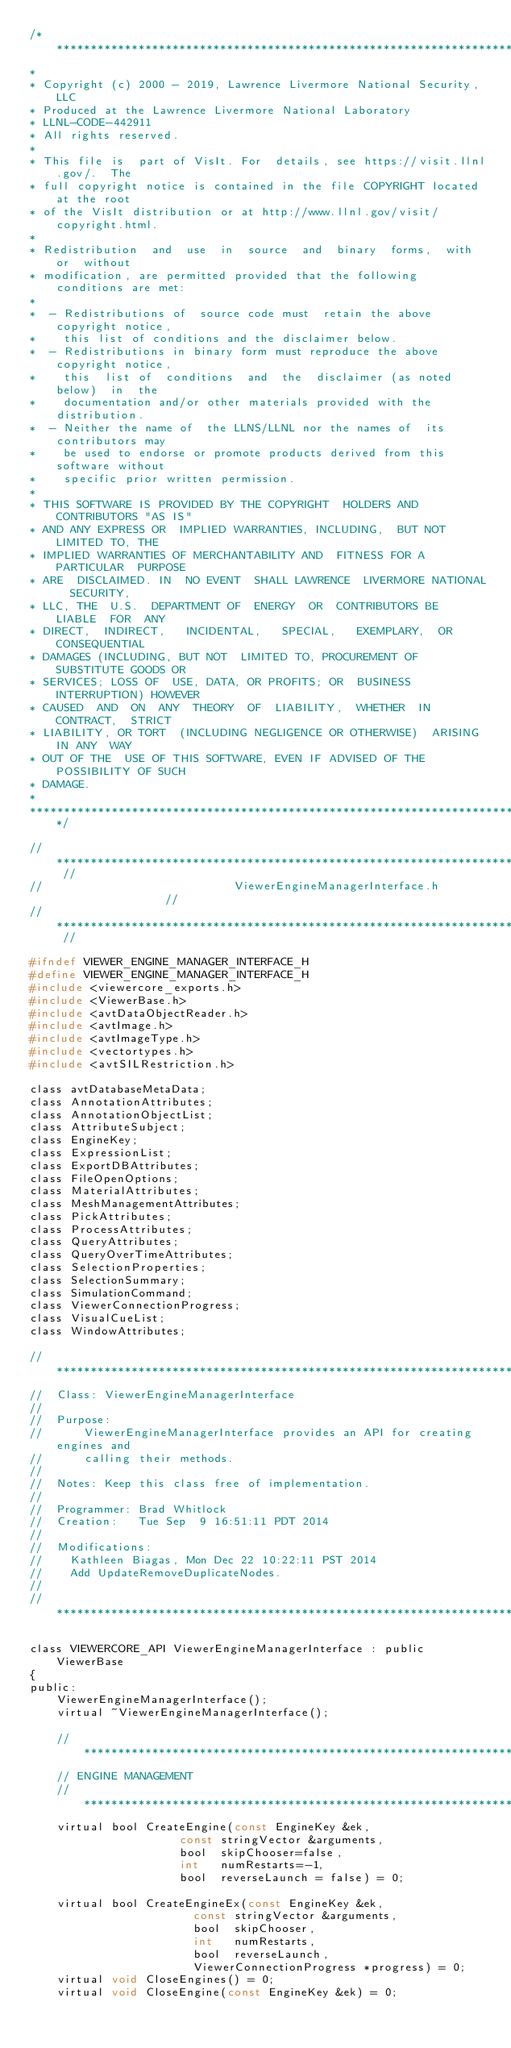Convert code to text. <code><loc_0><loc_0><loc_500><loc_500><_C_>/*****************************************************************************
*
* Copyright (c) 2000 - 2019, Lawrence Livermore National Security, LLC
* Produced at the Lawrence Livermore National Laboratory
* LLNL-CODE-442911
* All rights reserved.
*
* This file is  part of VisIt. For  details, see https://visit.llnl.gov/.  The
* full copyright notice is contained in the file COPYRIGHT located at the root
* of the VisIt distribution or at http://www.llnl.gov/visit/copyright.html.
*
* Redistribution  and  use  in  source  and  binary  forms,  with  or  without
* modification, are permitted provided that the following conditions are met:
*
*  - Redistributions of  source code must  retain the above  copyright notice,
*    this list of conditions and the disclaimer below.
*  - Redistributions in binary form must reproduce the above copyright notice,
*    this  list of  conditions  and  the  disclaimer (as noted below)  in  the
*    documentation and/or other materials provided with the distribution.
*  - Neither the name of  the LLNS/LLNL nor the names of  its contributors may
*    be used to endorse or promote products derived from this software without
*    specific prior written permission.
*
* THIS SOFTWARE IS PROVIDED BY THE COPYRIGHT  HOLDERS AND CONTRIBUTORS "AS IS"
* AND ANY EXPRESS OR  IMPLIED WARRANTIES, INCLUDING,  BUT NOT  LIMITED TO, THE
* IMPLIED WARRANTIES OF MERCHANTABILITY AND  FITNESS FOR A PARTICULAR  PURPOSE
* ARE  DISCLAIMED. IN  NO EVENT  SHALL LAWRENCE  LIVERMORE NATIONAL  SECURITY,
* LLC, THE  U.S.  DEPARTMENT OF  ENERGY  OR  CONTRIBUTORS BE  LIABLE  FOR  ANY
* DIRECT,  INDIRECT,   INCIDENTAL,   SPECIAL,   EXEMPLARY,  OR   CONSEQUENTIAL
* DAMAGES (INCLUDING, BUT NOT  LIMITED TO, PROCUREMENT OF  SUBSTITUTE GOODS OR
* SERVICES; LOSS OF  USE, DATA, OR PROFITS; OR  BUSINESS INTERRUPTION) HOWEVER
* CAUSED  AND  ON  ANY  THEORY  OF  LIABILITY,  WHETHER  IN  CONTRACT,  STRICT
* LIABILITY, OR TORT  (INCLUDING NEGLIGENCE OR OTHERWISE)  ARISING IN ANY  WAY
* OUT OF THE  USE OF THIS SOFTWARE, EVEN IF ADVISED OF THE POSSIBILITY OF SUCH
* DAMAGE.
*
*****************************************************************************/

// ************************************************************************* //
//                            ViewerEngineManagerInterface.h                 //
// ************************************************************************* //

#ifndef VIEWER_ENGINE_MANAGER_INTERFACE_H
#define VIEWER_ENGINE_MANAGER_INTERFACE_H
#include <viewercore_exports.h>
#include <ViewerBase.h>
#include <avtDataObjectReader.h>
#include <avtImage.h>
#include <avtImageType.h>
#include <vectortypes.h>
#include <avtSILRestriction.h>

class avtDatabaseMetaData;
class AnnotationAttributes;
class AnnotationObjectList;
class AttributeSubject;
class EngineKey;
class ExpressionList;
class ExportDBAttributes;
class FileOpenOptions;
class MaterialAttributes;
class MeshManagementAttributes;
class PickAttributes;
class ProcessAttributes;
class QueryAttributes;
class QueryOverTimeAttributes;
class SelectionProperties;
class SelectionSummary;
class SimulationCommand;
class ViewerConnectionProgress;
class VisualCueList;
class WindowAttributes;

// ****************************************************************************
//  Class: ViewerEngineManagerInterface
//
//  Purpose:
//      ViewerEngineManagerInterface provides an API for creating engines and
//      calling their methods.
//
//  Notes: Keep this class free of implementation.
//
//  Programmer: Brad Whitlock
//  Creation:   Tue Sep  9 16:51:11 PDT 2014
//
//  Modifications:
//    Kathleen Biagas, Mon Dec 22 10:22:11 PST 2014
//    Add UpdateRemoveDuplicateNodes.
//
// ****************************************************************************

class VIEWERCORE_API ViewerEngineManagerInterface : public ViewerBase
{
public:
    ViewerEngineManagerInterface();
    virtual ~ViewerEngineManagerInterface();

    // *********************************************************************
    // ENGINE MANAGEMENT
    // *********************************************************************
    virtual bool CreateEngine(const EngineKey &ek,
                      const stringVector &arguments,
                      bool  skipChooser=false,
                      int   numRestarts=-1,
                      bool  reverseLaunch = false) = 0;

    virtual bool CreateEngineEx(const EngineKey &ek,
                        const stringVector &arguments,
                        bool  skipChooser,
                        int   numRestarts,
                        bool  reverseLaunch,
                        ViewerConnectionProgress *progress) = 0;
    virtual void CloseEngines() = 0;
    virtual void CloseEngine(const EngineKey &ek) = 0;</code> 